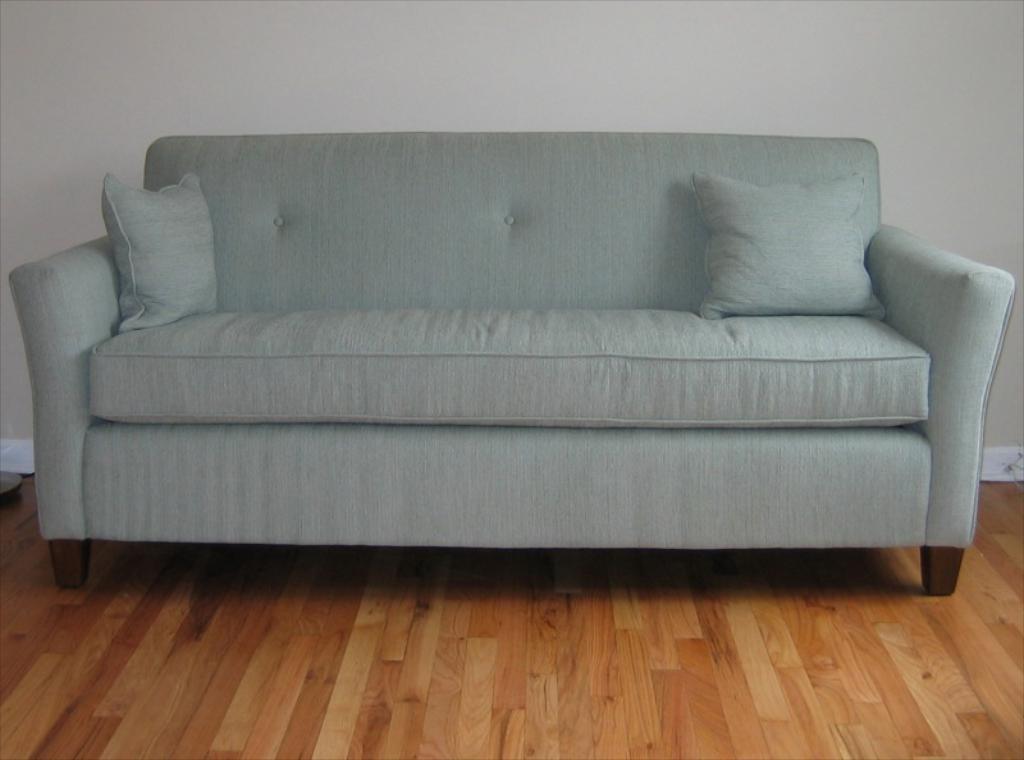How would you summarize this image in a sentence or two? There is a room. There is a sofa in a room. 